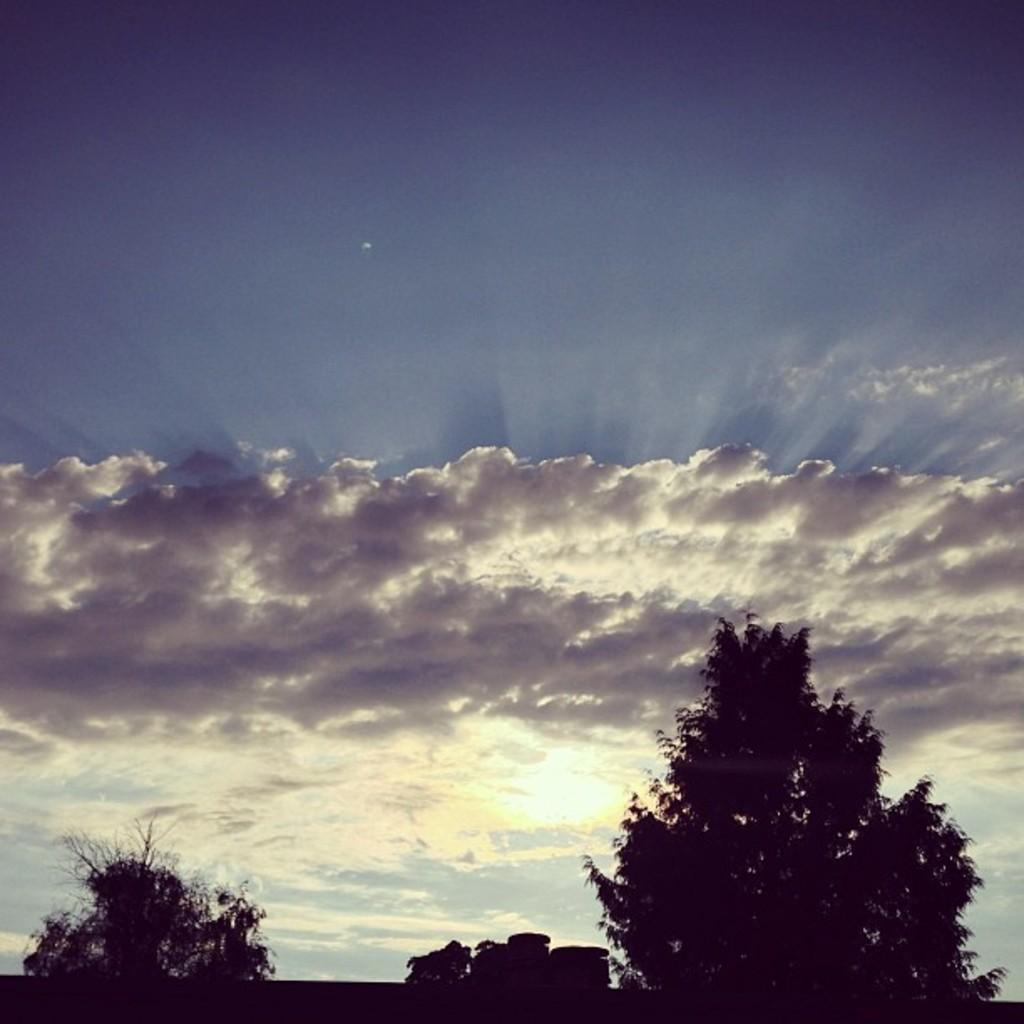What type of vegetation can be seen at the bottom side of the image? There are trees at the bottom side of the image. What part of the natural environment is visible at the top side of the image? The sky is visible at the top side of the image. How many queens are playing with the boys during the thunderstorm in the image? There is no reference to a queen, boys, or thunderstorm in the image, so it is not possible to answer that question. 